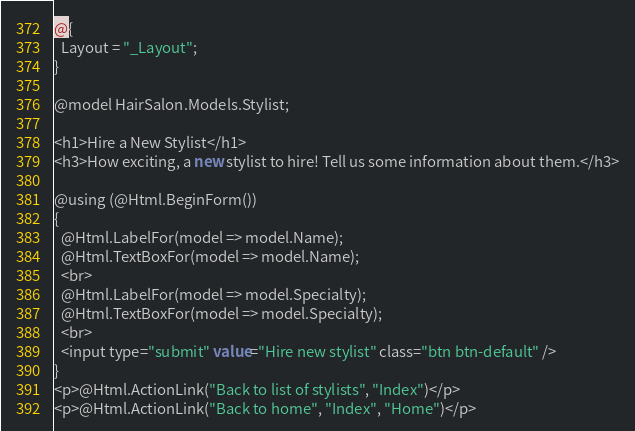Convert code to text. <code><loc_0><loc_0><loc_500><loc_500><_C#_>@{
  Layout = "_Layout";
}

@model HairSalon.Models.Stylist;

<h1>Hire a New Stylist</h1>
<h3>How exciting, a new stylist to hire! Tell us some information about them.</h3>

@using (@Html.BeginForm())
{
  @Html.LabelFor(model => model.Name);
  @Html.TextBoxFor(model => model.Name);
  <br>
  @Html.LabelFor(model => model.Specialty);
  @Html.TextBoxFor(model => model.Specialty);
  <br>
  <input type="submit" value="Hire new stylist" class="btn btn-default" />
}
<p>@Html.ActionLink("Back to list of stylists", "Index")</p>
<p>@Html.ActionLink("Back to home", "Index", "Home")</p></code> 